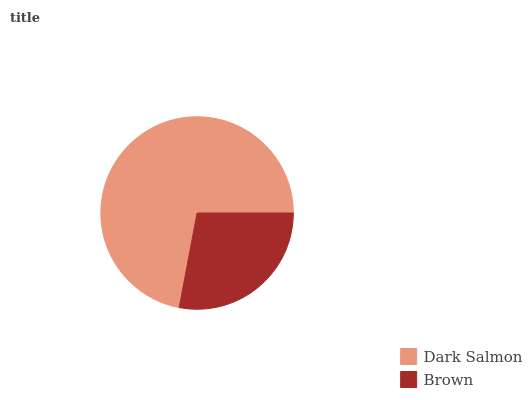Is Brown the minimum?
Answer yes or no. Yes. Is Dark Salmon the maximum?
Answer yes or no. Yes. Is Brown the maximum?
Answer yes or no. No. Is Dark Salmon greater than Brown?
Answer yes or no. Yes. Is Brown less than Dark Salmon?
Answer yes or no. Yes. Is Brown greater than Dark Salmon?
Answer yes or no. No. Is Dark Salmon less than Brown?
Answer yes or no. No. Is Dark Salmon the high median?
Answer yes or no. Yes. Is Brown the low median?
Answer yes or no. Yes. Is Brown the high median?
Answer yes or no. No. Is Dark Salmon the low median?
Answer yes or no. No. 